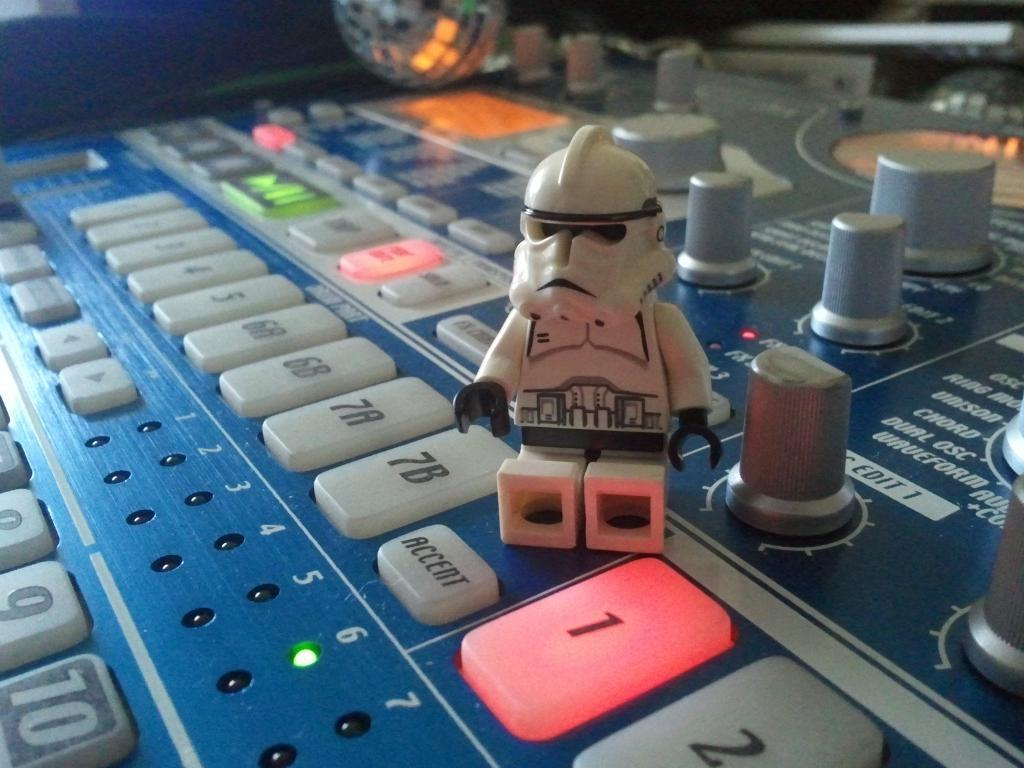<image>
Provide a brief description of the given image. a board that has numbers on it with the number 1 lit up in red 